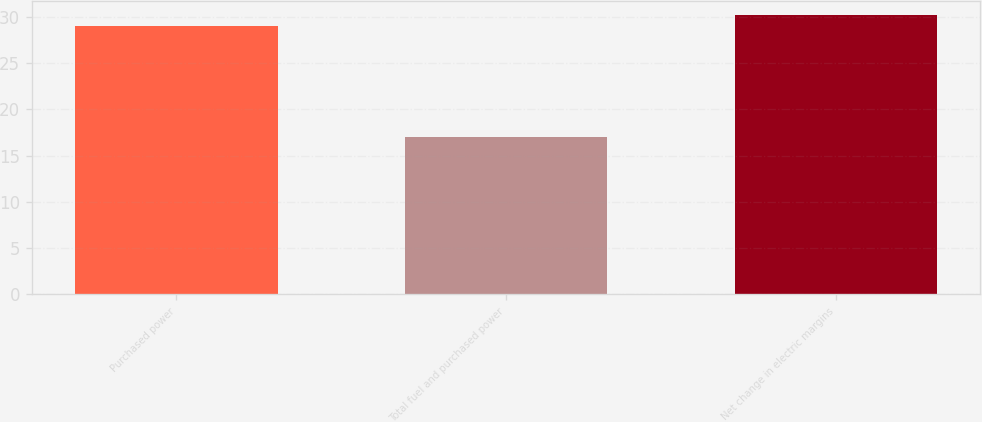Convert chart to OTSL. <chart><loc_0><loc_0><loc_500><loc_500><bar_chart><fcel>Purchased power<fcel>Total fuel and purchased power<fcel>Net change in electric margins<nl><fcel>29<fcel>17<fcel>30.2<nl></chart> 